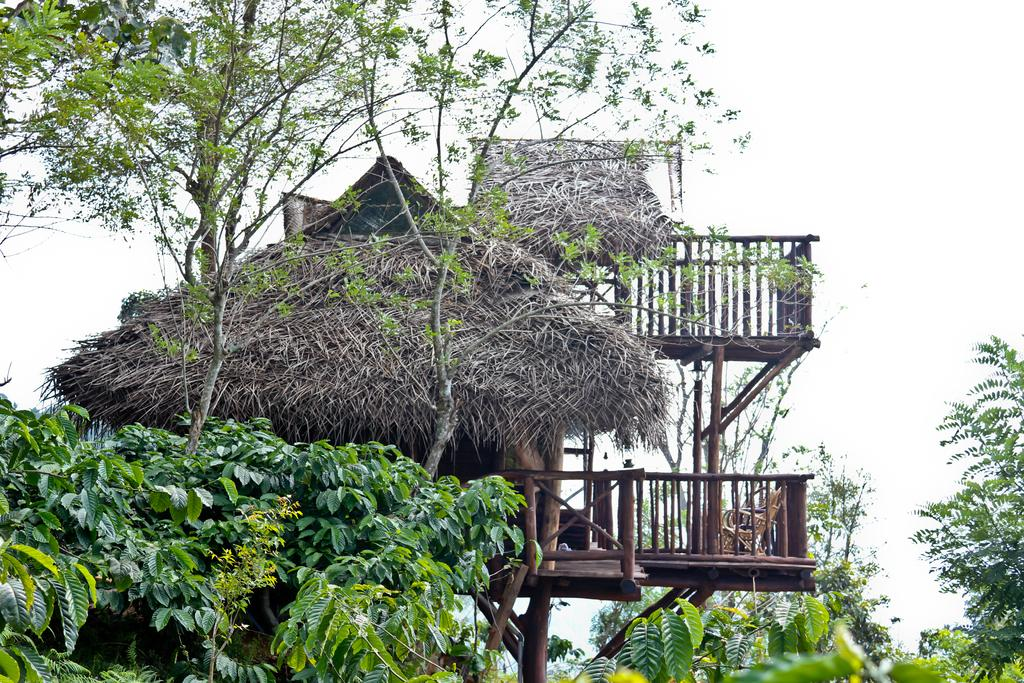What type of house is in the image? There is a wooden house in the image. What other natural elements can be seen in the image? There are trees in the image. What is the condition of the sky in the image? The sky is cloudy in the image. Where is the flame located in the image? There is no flame present in the image. What type of map is shown in the image? There is no map present in the image. How many screws can be seen in the image? There are no screws present in the image. 